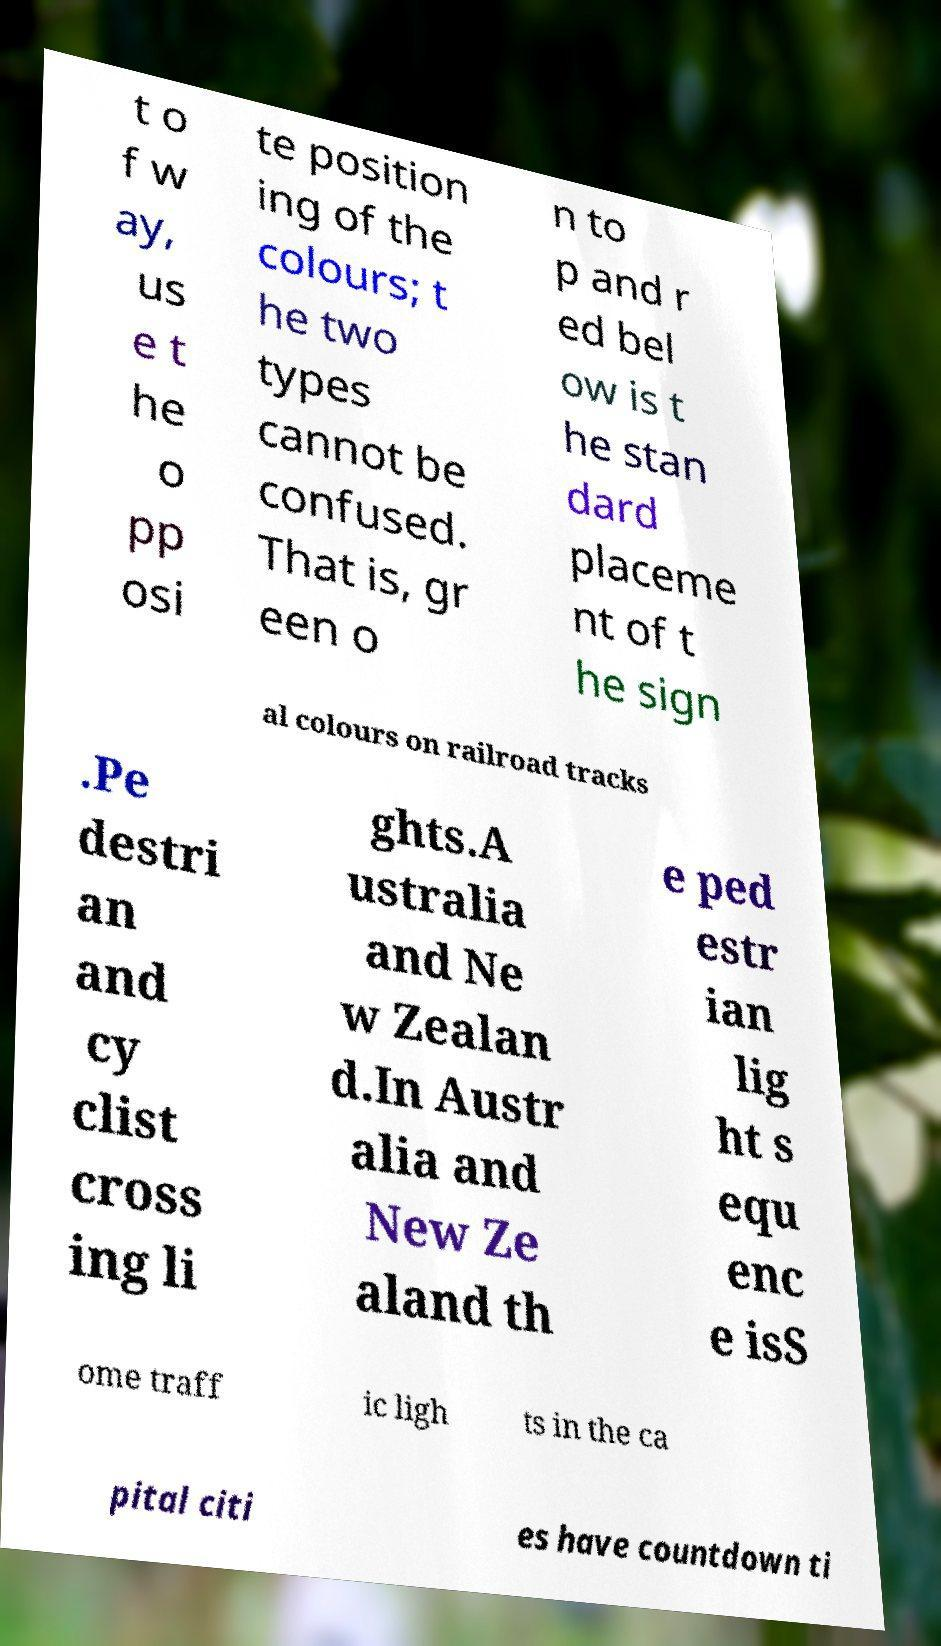Could you assist in decoding the text presented in this image and type it out clearly? t o f w ay, us e t he o pp osi te position ing of the colours; t he two types cannot be confused. That is, gr een o n to p and r ed bel ow is t he stan dard placeme nt of t he sign al colours on railroad tracks .Pe destri an and cy clist cross ing li ghts.A ustralia and Ne w Zealan d.In Austr alia and New Ze aland th e ped estr ian lig ht s equ enc e isS ome traff ic ligh ts in the ca pital citi es have countdown ti 